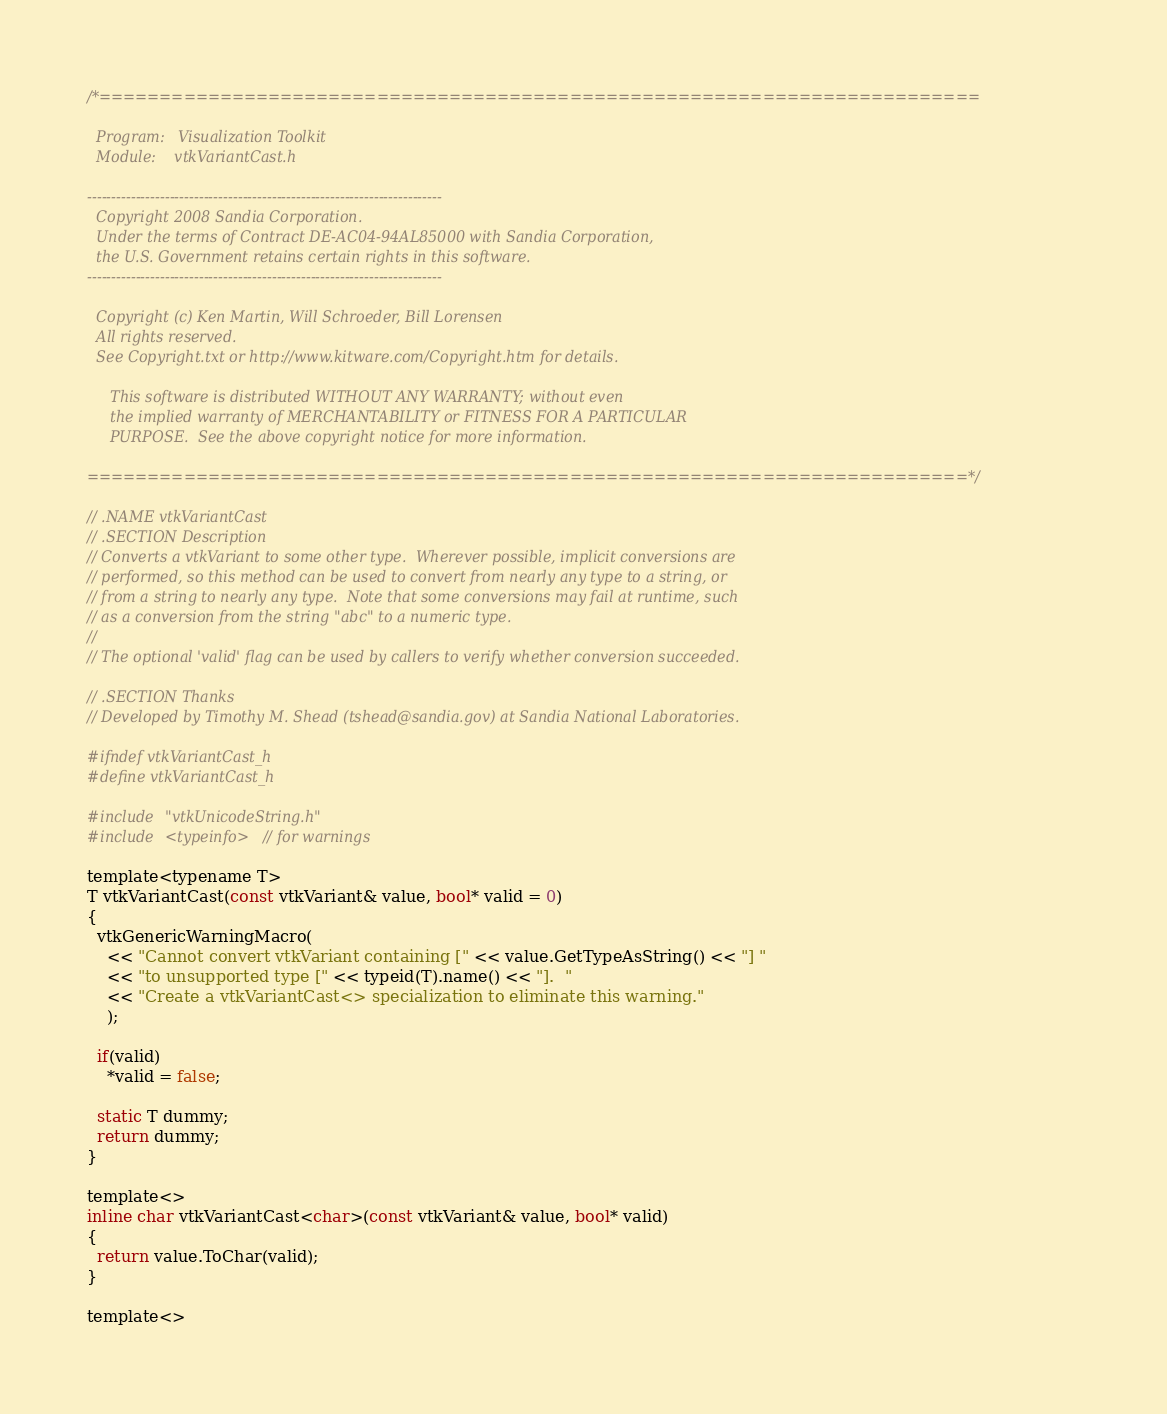Convert code to text. <code><loc_0><loc_0><loc_500><loc_500><_C_>/*=========================================================================

  Program:   Visualization Toolkit
  Module:    vtkVariantCast.h

-------------------------------------------------------------------------
  Copyright 2008 Sandia Corporation.
  Under the terms of Contract DE-AC04-94AL85000 with Sandia Corporation,
  the U.S. Government retains certain rights in this software.
-------------------------------------------------------------------------

  Copyright (c) Ken Martin, Will Schroeder, Bill Lorensen
  All rights reserved.
  See Copyright.txt or http://www.kitware.com/Copyright.htm for details.

     This software is distributed WITHOUT ANY WARRANTY; without even
     the implied warranty of MERCHANTABILITY or FITNESS FOR A PARTICULAR
     PURPOSE.  See the above copyright notice for more information.

=========================================================================*/

// .NAME vtkVariantCast
// .SECTION Description
// Converts a vtkVariant to some other type.  Wherever possible, implicit conversions are
// performed, so this method can be used to convert from nearly any type to a string, or
// from a string to nearly any type.  Note that some conversions may fail at runtime, such
// as a conversion from the string "abc" to a numeric type.
//
// The optional 'valid' flag can be used by callers to verify whether conversion succeeded.

// .SECTION Thanks
// Developed by Timothy M. Shead (tshead@sandia.gov) at Sandia National Laboratories.

#ifndef vtkVariantCast_h
#define vtkVariantCast_h

#include "vtkUnicodeString.h"
#include <typeinfo> // for warnings

template<typename T>
T vtkVariantCast(const vtkVariant& value, bool* valid = 0)
{
  vtkGenericWarningMacro(
    << "Cannot convert vtkVariant containing [" << value.GetTypeAsString() << "] "
    << "to unsupported type [" << typeid(T).name() << "].  "
    << "Create a vtkVariantCast<> specialization to eliminate this warning."
    );

  if(valid)
    *valid = false;

  static T dummy;
  return dummy;
}

template<>
inline char vtkVariantCast<char>(const vtkVariant& value, bool* valid)
{
  return value.ToChar(valid);
}

template<></code> 